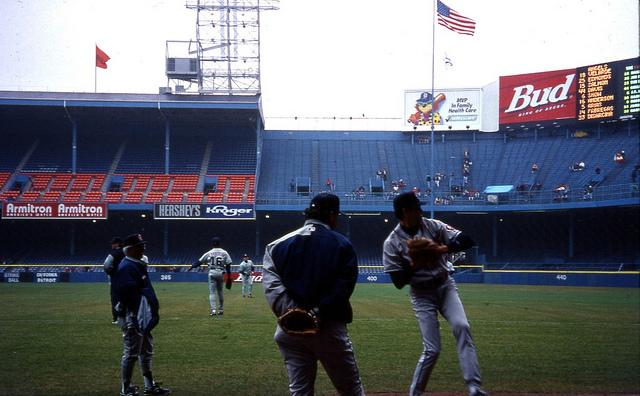Which advertiser is a watch company? armitron 